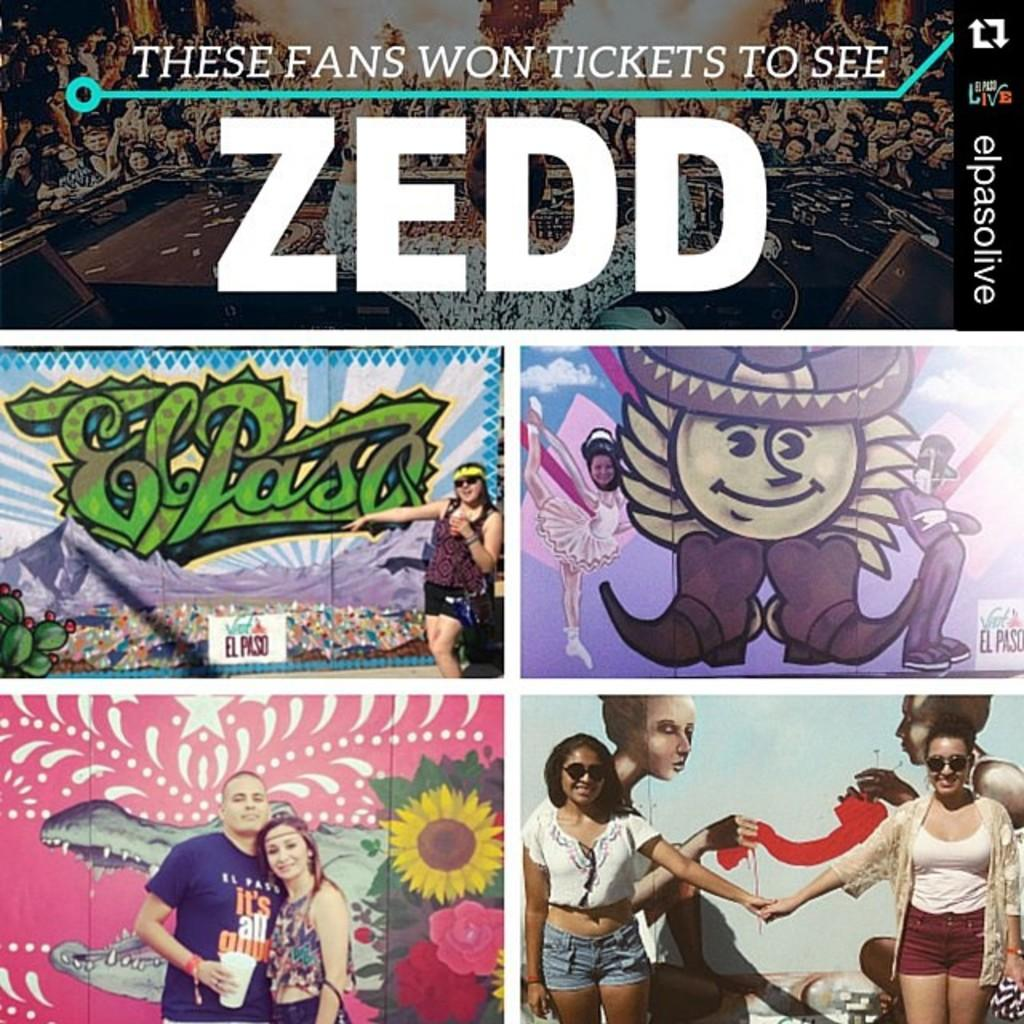<image>
Create a compact narrative representing the image presented. a collage of people who Won Ticket to See Zedd 